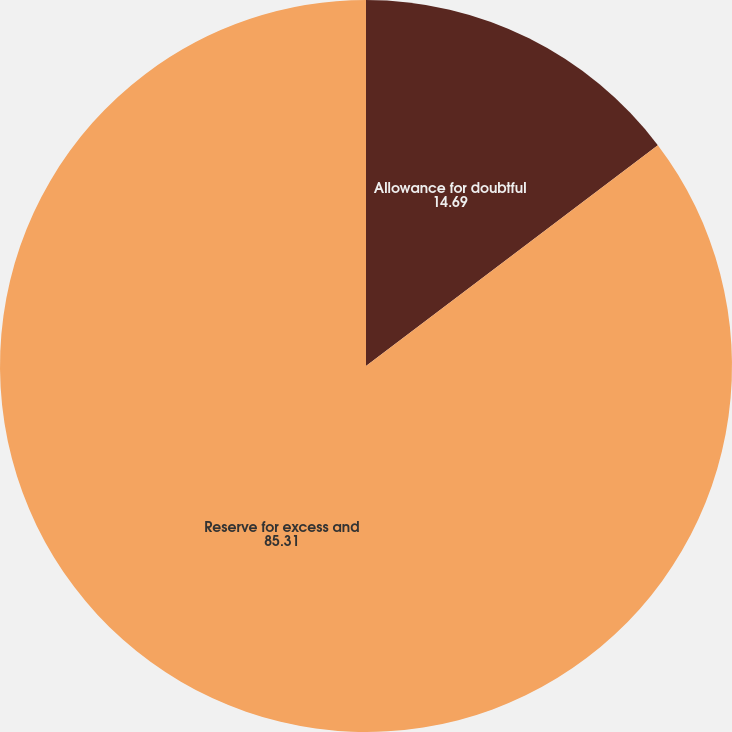<chart> <loc_0><loc_0><loc_500><loc_500><pie_chart><fcel>Allowance for doubtful<fcel>Reserve for excess and<nl><fcel>14.69%<fcel>85.31%<nl></chart> 